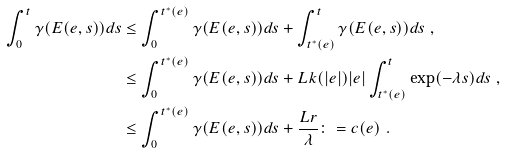<formula> <loc_0><loc_0><loc_500><loc_500>\int _ { 0 } ^ { t } \gamma ( E ( e , s ) ) d s & \leq \int _ { 0 } ^ { t ^ { * } ( e ) } \gamma ( E ( e , s ) ) d s + \int _ { t ^ { * } ( e ) } ^ { t } \gamma ( E ( e , s ) ) d s \ , \\ & \leq \int _ { 0 } ^ { t ^ { * } ( e ) } \gamma ( E ( e , s ) ) d s + L k ( | e | ) | e | \int _ { t ^ { * } ( e ) } ^ { t } \exp ( - \lambda s ) d s \ , \\ & \leq \int _ { 0 } ^ { t ^ { * } ( e ) } \gamma ( E ( e , s ) ) d s + \frac { L r } { \lambda } \colon = c ( e ) \ .</formula> 